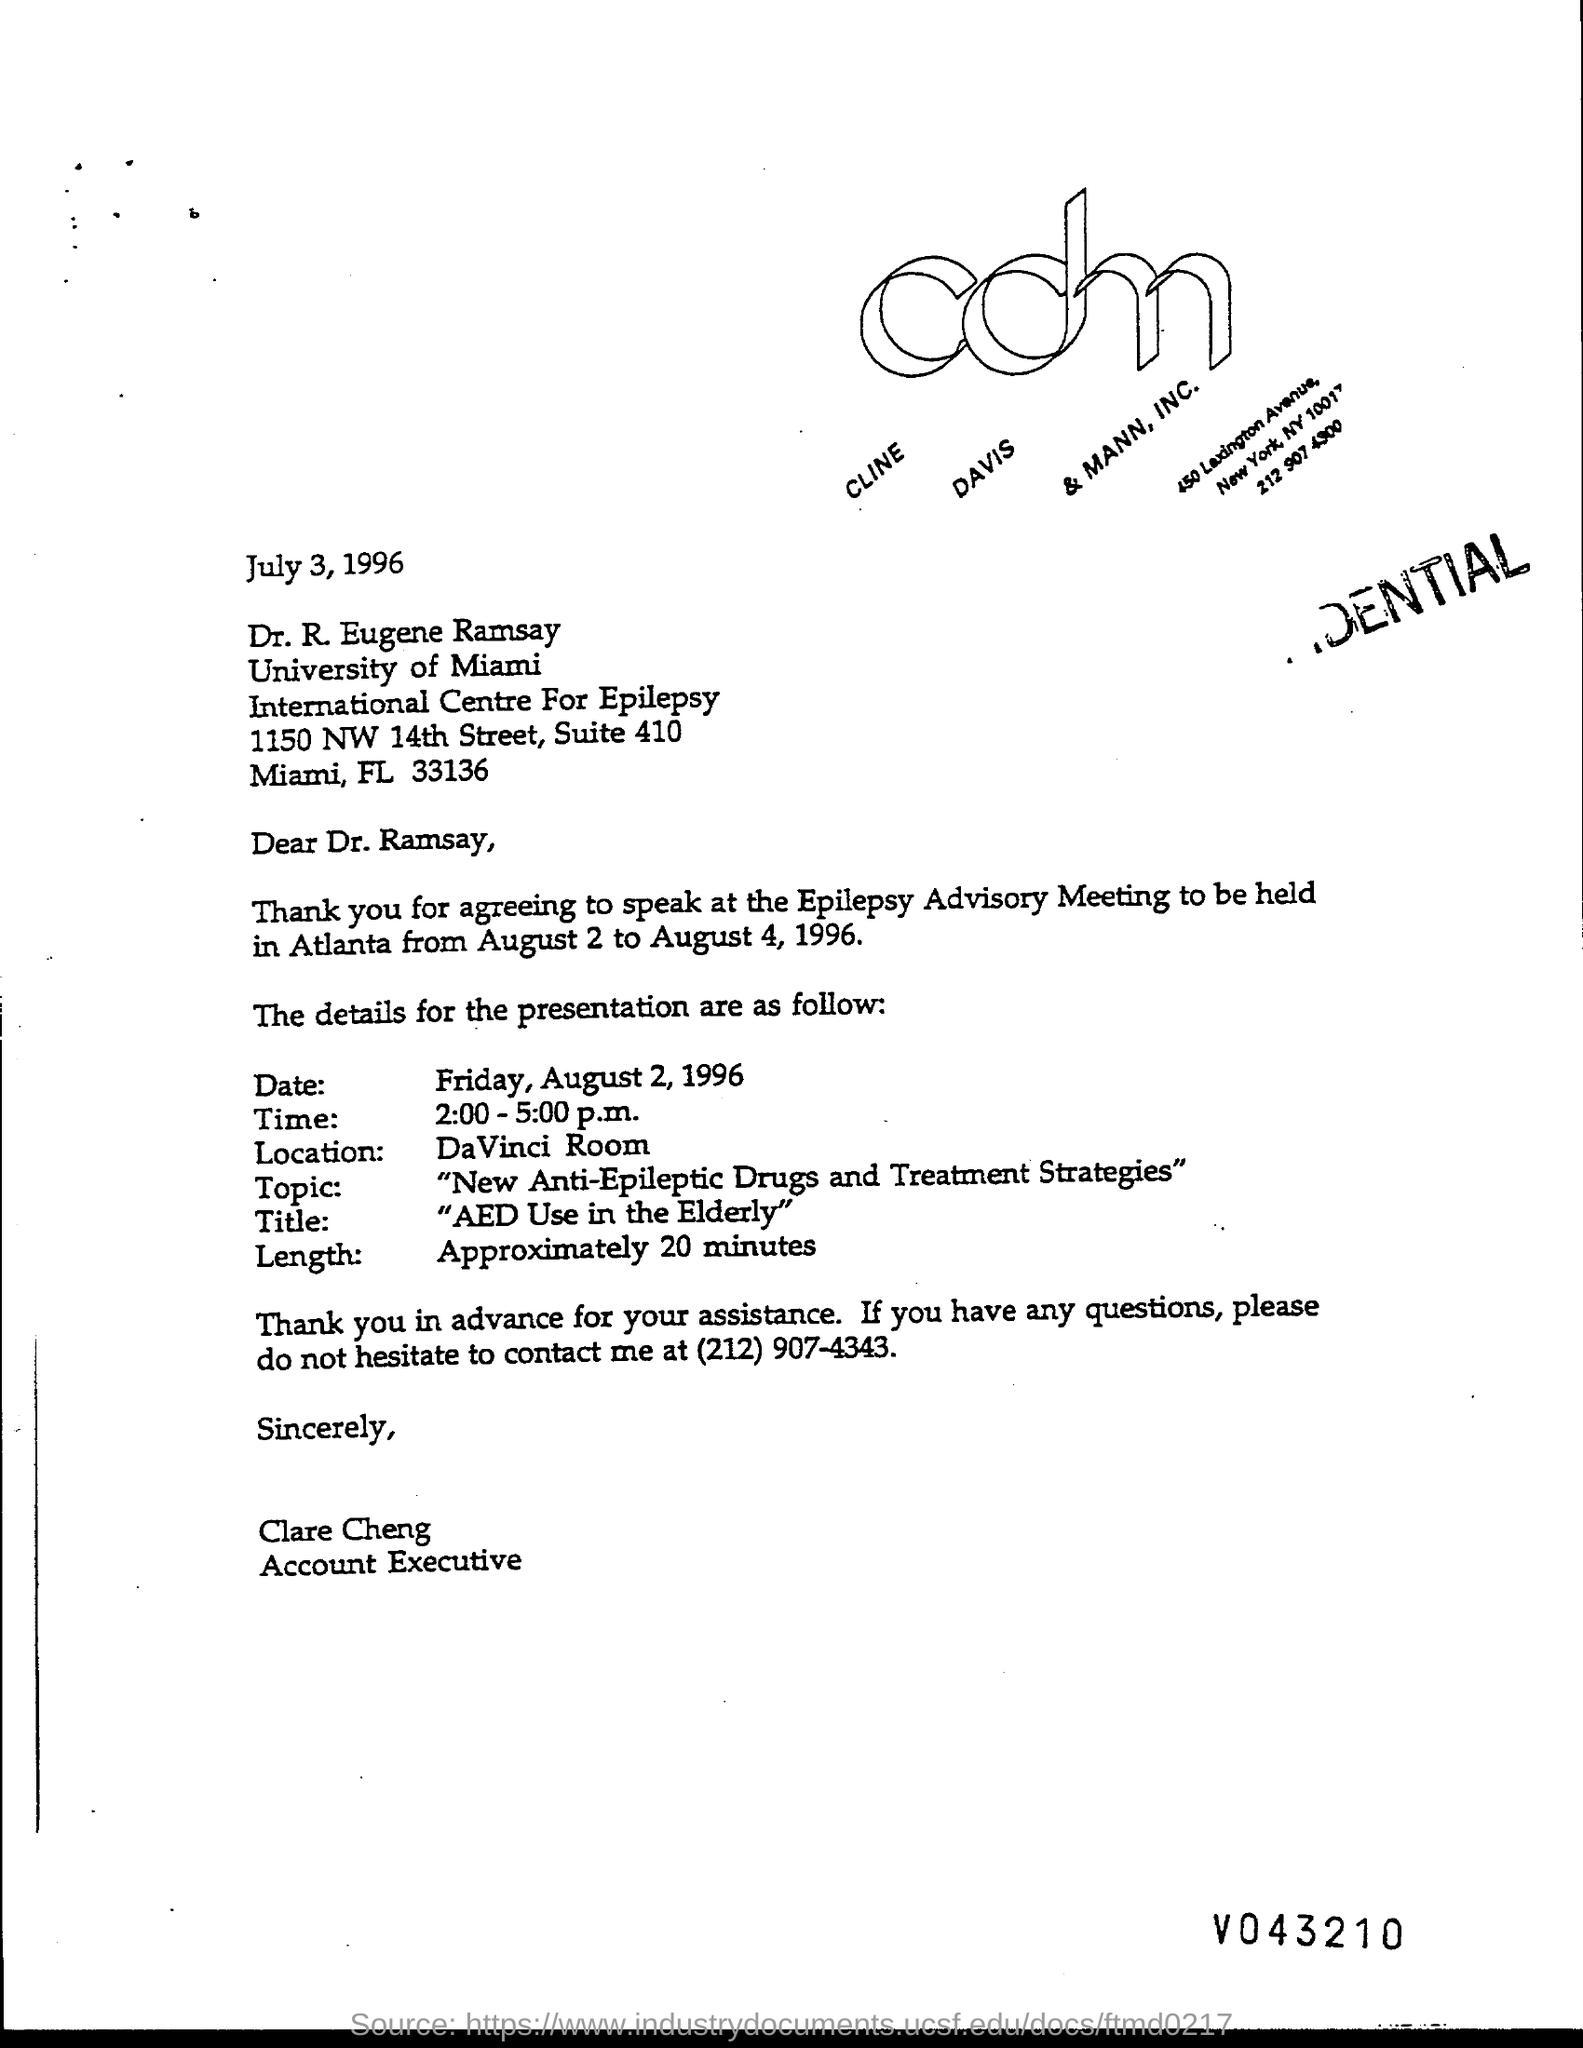List a handful of essential elements in this visual. The presentation is scheduled for August 2, 1996. The title of the presentation is "AED Use in the Elderly. Clare Cheng is currently employed as an Account Executive. The letter is dated July 3, 1996. The street address of the International Centre for Epilepsy is 1150 NW 14TH STREET. 